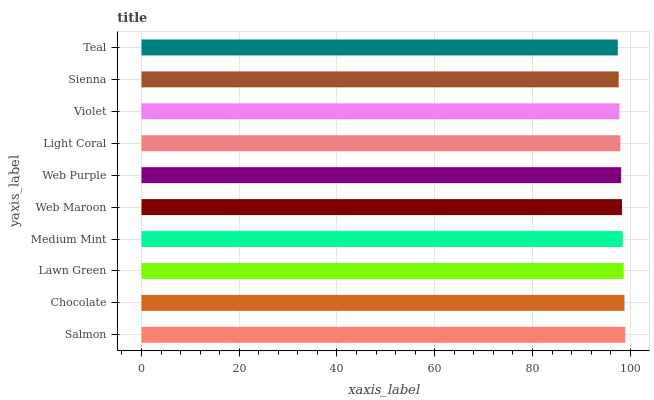Is Teal the minimum?
Answer yes or no. Yes. Is Salmon the maximum?
Answer yes or no. Yes. Is Chocolate the minimum?
Answer yes or no. No. Is Chocolate the maximum?
Answer yes or no. No. Is Salmon greater than Chocolate?
Answer yes or no. Yes. Is Chocolate less than Salmon?
Answer yes or no. Yes. Is Chocolate greater than Salmon?
Answer yes or no. No. Is Salmon less than Chocolate?
Answer yes or no. No. Is Web Maroon the high median?
Answer yes or no. Yes. Is Web Purple the low median?
Answer yes or no. Yes. Is Web Purple the high median?
Answer yes or no. No. Is Salmon the low median?
Answer yes or no. No. 